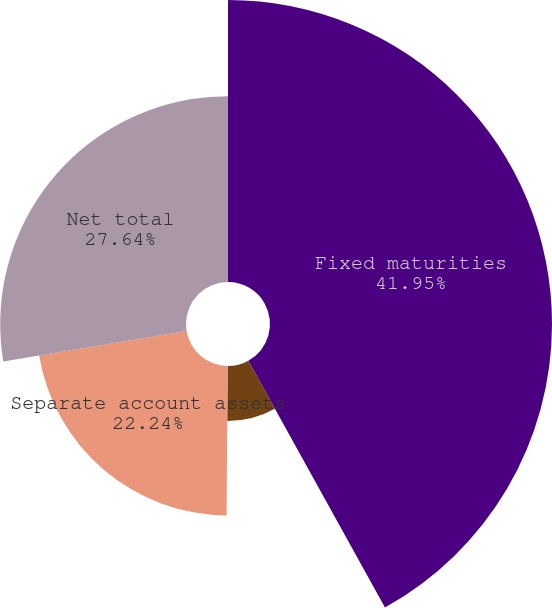Convert chart to OTSL. <chart><loc_0><loc_0><loc_500><loc_500><pie_chart><fcel>Fixed maturities<fcel>Equity securities<fcel>Separate account assets<fcel>Net total<nl><fcel>41.95%<fcel>8.17%<fcel>22.24%<fcel>27.64%<nl></chart> 